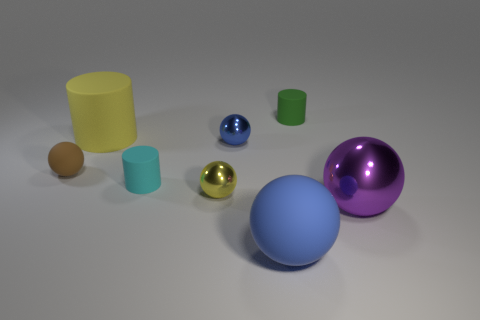Are there more big matte objects that are in front of the brown rubber sphere than big cyan matte balls?
Provide a succinct answer. Yes. The purple metal thing that is the same shape as the blue metal object is what size?
Provide a short and direct response. Large. What is the shape of the cyan thing?
Offer a terse response. Cylinder. What is the shape of the cyan object that is the same size as the blue shiny object?
Give a very brief answer. Cylinder. Is there anything else that has the same color as the big cylinder?
Your answer should be very brief. Yes. What is the size of the blue object that is made of the same material as the yellow cylinder?
Offer a very short reply. Large. There is a big yellow rubber object; does it have the same shape as the purple shiny thing behind the large blue rubber thing?
Offer a terse response. No. How big is the purple metallic thing?
Keep it short and to the point. Large. Is the number of small green cylinders that are in front of the green matte object less than the number of green balls?
Make the answer very short. No. What number of matte cylinders have the same size as the yellow metal ball?
Your response must be concise. 2. 